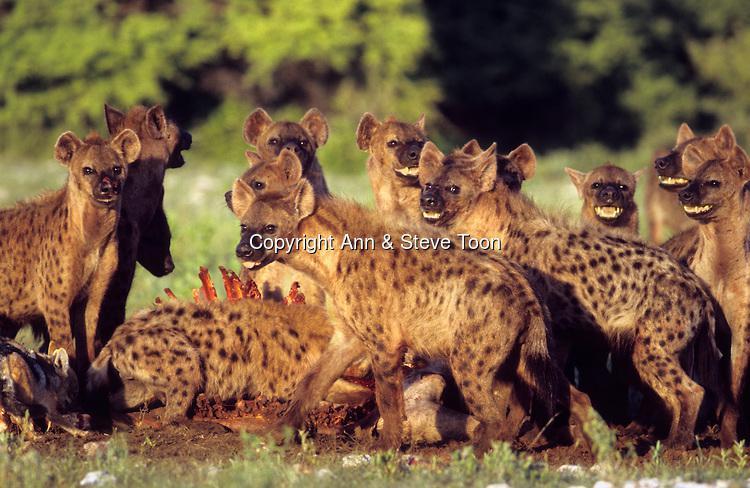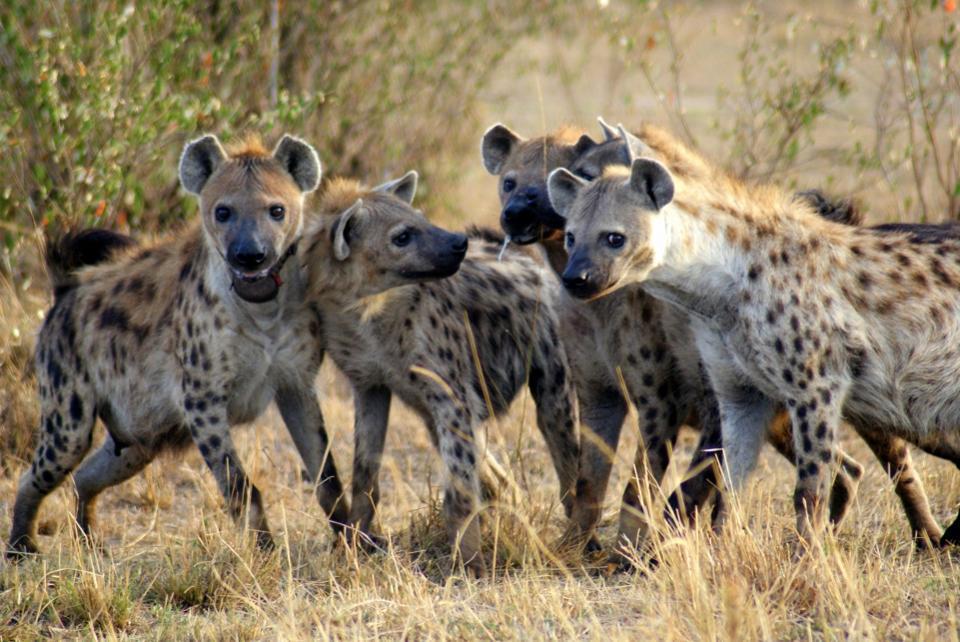The first image is the image on the left, the second image is the image on the right. Examine the images to the left and right. Is the description "An image shows an animal with fangs bared surrounded by hyenas." accurate? Answer yes or no. No. 